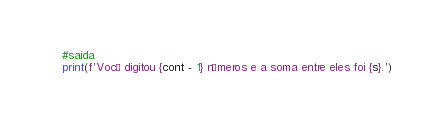Convert code to text. <code><loc_0><loc_0><loc_500><loc_500><_Python_>
#saida
print(f'Você digitou {cont - 1} números e a soma entre eles foi {s}.')
</code> 